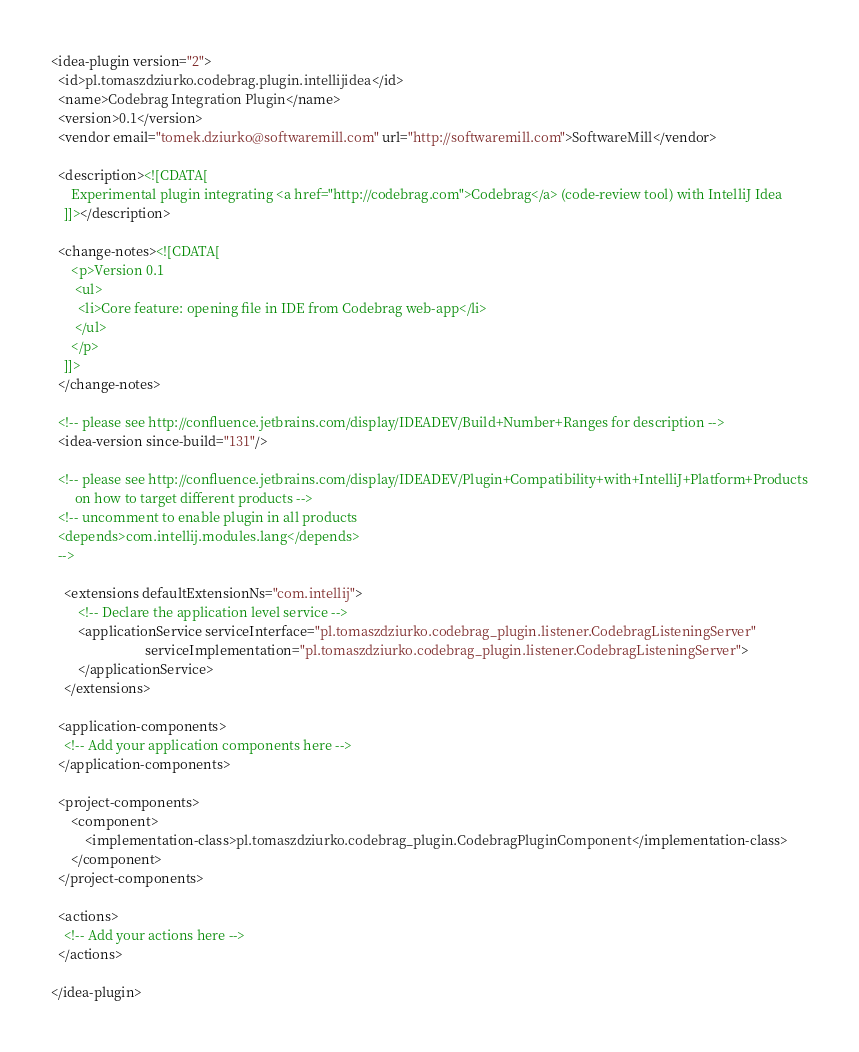<code> <loc_0><loc_0><loc_500><loc_500><_XML_><idea-plugin version="2">
  <id>pl.tomaszdziurko.codebrag.plugin.intellijidea</id>
  <name>Codebrag Integration Plugin</name>
  <version>0.1</version>
  <vendor email="tomek.dziurko@softwaremill.com" url="http://softwaremill.com">SoftwareMill</vendor>

  <description><![CDATA[
      Experimental plugin integrating <a href="http://codebrag.com">Codebrag</a> (code-review tool) with IntelliJ Idea
    ]]></description>

  <change-notes><![CDATA[
      <p>Version 0.1
       <ul>
        <li>Core feature: opening file in IDE from Codebrag web-app</li>
       </ul>
      </p>
    ]]>
  </change-notes>

  <!-- please see http://confluence.jetbrains.com/display/IDEADEV/Build+Number+Ranges for description -->
  <idea-version since-build="131"/>

  <!-- please see http://confluence.jetbrains.com/display/IDEADEV/Plugin+Compatibility+with+IntelliJ+Platform+Products
       on how to target different products -->
  <!-- uncomment to enable plugin in all products
  <depends>com.intellij.modules.lang</depends>
  -->

    <extensions defaultExtensionNs="com.intellij">
        <!-- Declare the application level service -->
        <applicationService serviceInterface="pl.tomaszdziurko.codebrag_plugin.listener.CodebragListeningServer"
                            serviceImplementation="pl.tomaszdziurko.codebrag_plugin.listener.CodebragListeningServer">
        </applicationService>
    </extensions>

  <application-components>
    <!-- Add your application components here -->
  </application-components>

  <project-components>
      <component>
          <implementation-class>pl.tomaszdziurko.codebrag_plugin.CodebragPluginComponent</implementation-class>
      </component>
  </project-components>

  <actions>
    <!-- Add your actions here -->
  </actions>

</idea-plugin></code> 